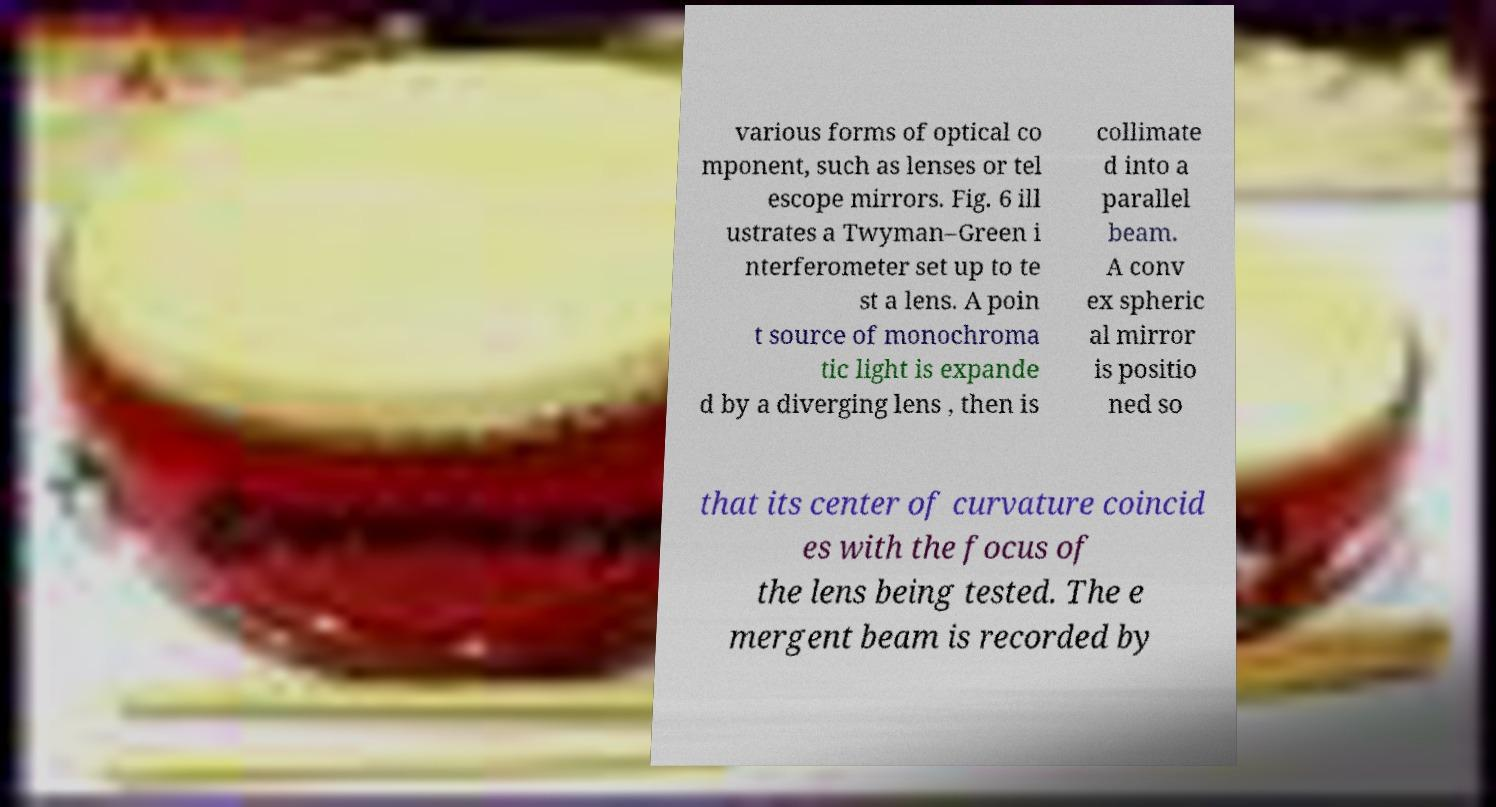Could you extract and type out the text from this image? various forms of optical co mponent, such as lenses or tel escope mirrors. Fig. 6 ill ustrates a Twyman–Green i nterferometer set up to te st a lens. A poin t source of monochroma tic light is expande d by a diverging lens , then is collimate d into a parallel beam. A conv ex spheric al mirror is positio ned so that its center of curvature coincid es with the focus of the lens being tested. The e mergent beam is recorded by 